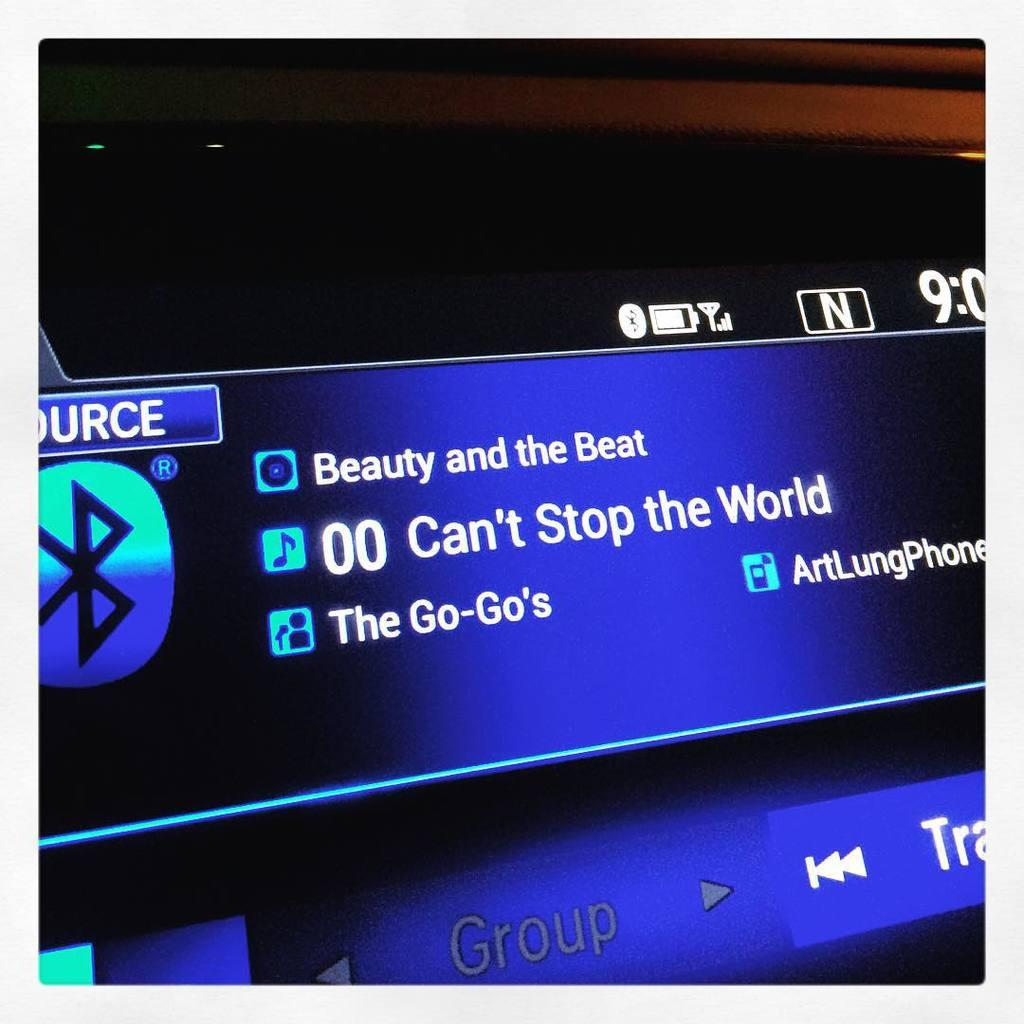Provide a one-sentence caption for the provided image. A computer is playing the song Beauty and the Beat. 